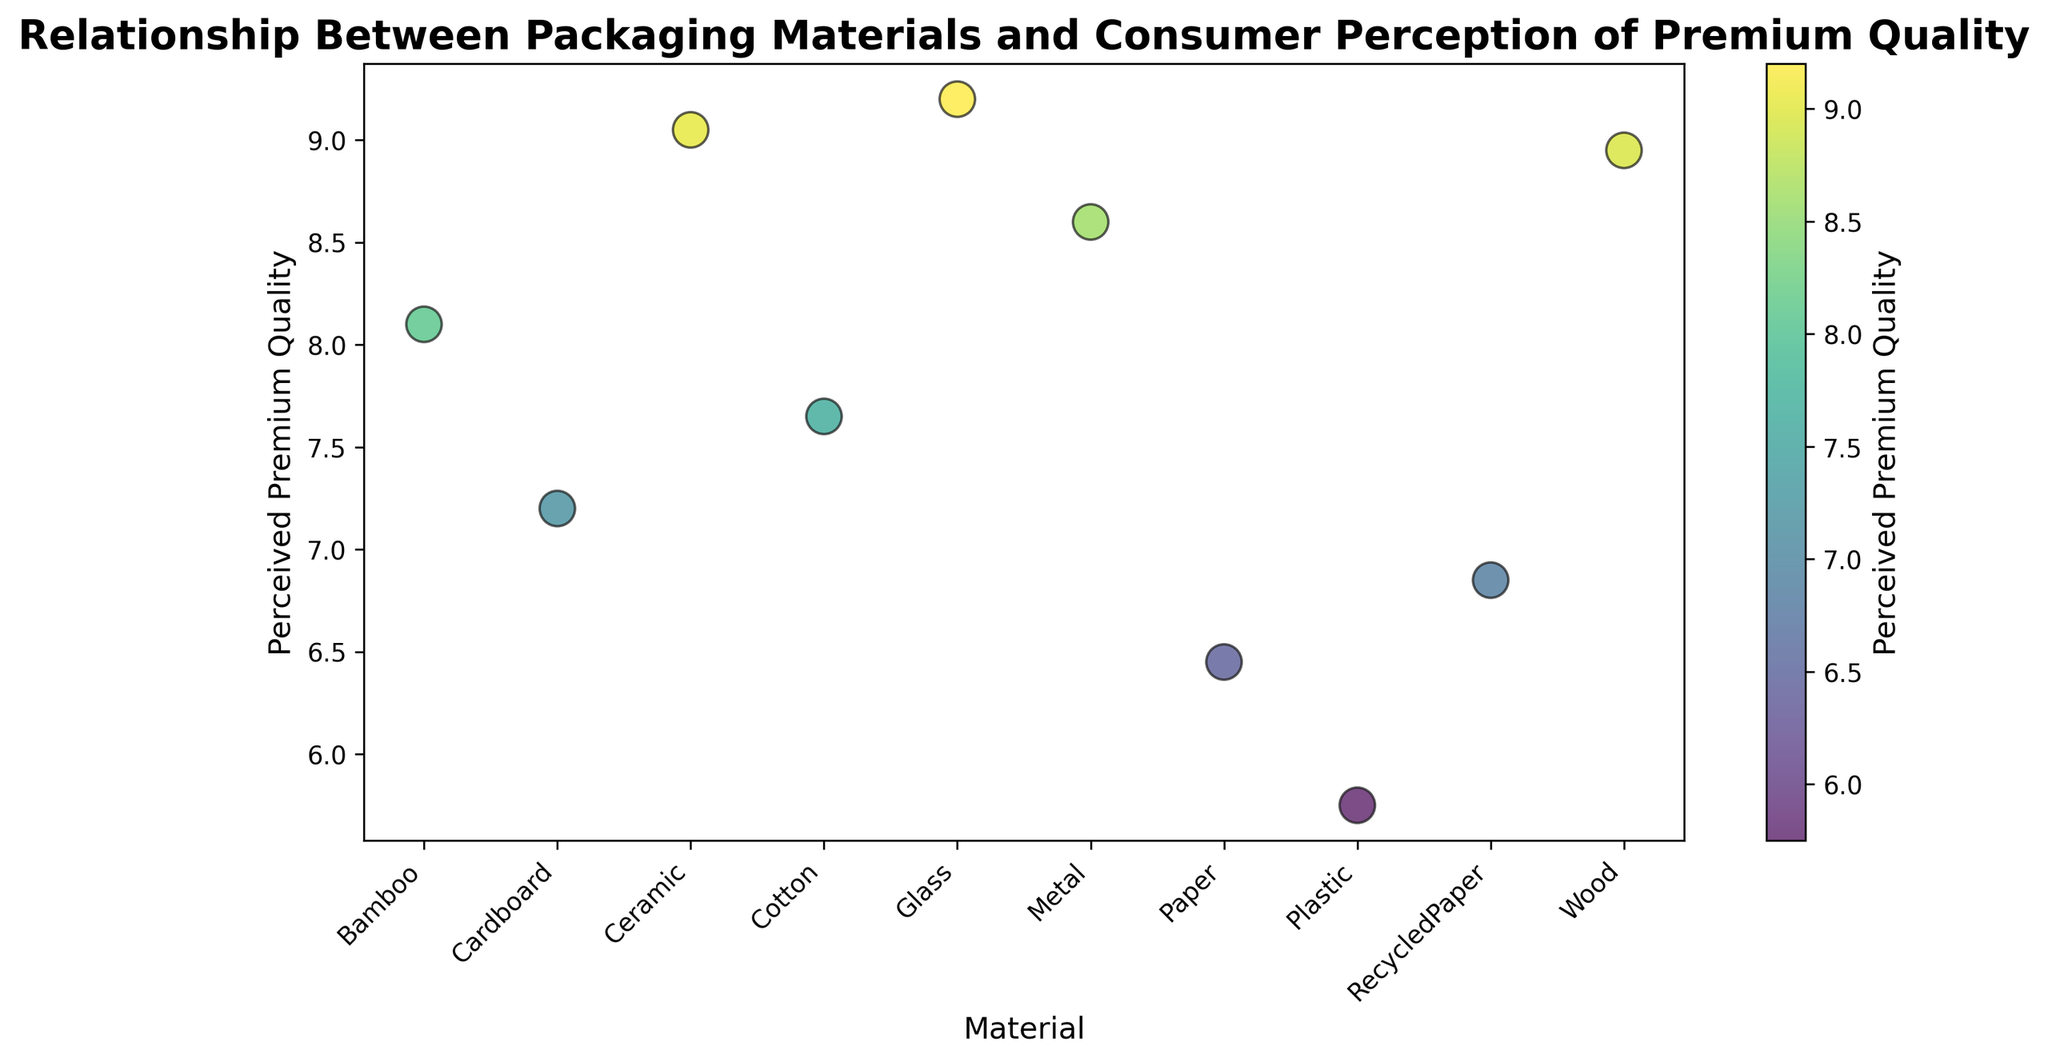Which material is perceived to have the highest premium quality? From the scatter plot, we can observe the y-axis values and see that 'Glass' ranks the highest in perceived premium quality with a rating of approximately 9.2.
Answer: Glass Which material has the lowest perceived premium quality? By examining the scatter plot, 'Plastic' appears at the lowest position on the y-axis, indicating it has the lowest perceived premium quality with an approximate rating of 5.75.
Answer: Plastic What is the perceived premium quality difference between 'Glass' and 'Plastic'? Locate 'Glass' and 'Plastic' on the scatter plot. The top 'Glass' value is about 9.2 and 'Plastic' is about 5.75. Subtracting these values gives the difference: 9.2 - 5.75 = 3.45.
Answer: 3.45 Which materials have a perceived premium quality rating above 8? Identify the markers on the scatter plot with y-axis values over 8. These are: 'Glass', 'Metal', 'Wood', 'Ceramic', and 'Bamboo'.
Answer: Glass, Metal, Wood, Ceramic, Bamboo Is the perceived premium quality for 'Cardboard' greater than that for 'Paper'? From the scatter plot, 'Cardboard' has a perceived premium quality rating around 7.2, whereas 'Paper' has a rating around 6.45. Thus, 'Cardboard' is rated higher than 'Paper'.
Answer: Yes Which material shows the second highest perceived premium quality? The second-highest mark after 'Glass' on the scatter plot is 'Ceramic', with a rating slightly above 9.0.
Answer: Ceramic What is the average perceived premium quality of 'Glass' and 'Ceramic'? 'Glass' is approximately 9.2 and 'Ceramic' is about 9.05. Thus, their average is (9.2 + 9.05) / 2 = 9.125.
Answer: 9.125 How does the perceived premium quality of 'Wood' compare to 'Bamboo'? On the scatter plot, 'Wood' has an approximate rating of 9.0, while 'Bamboo' sits around 8.1. Comparatively, 'Wood' is rated higher than 'Bamboo'.
Answer: 'Wood' is rated higher What is the perceived premium quality difference between 'Metal' and 'Cotton'? 'Metal' has a perceived premium quality around 8.6 and 'Cotton' around 7.65. The difference is 8.6 - 7.65 = 0.95.
Answer: 0.95 Does 'RecycledPaper' have a higher perceived premium quality than 'Plastic'? From the scatter plot, 'RecycledPaper' is rated around 6.85, while 'Plastic' is about 5.75. Therefore, 'RecycledPaper' has a higher perceived premium quality than 'Plastic'.
Answer: Yes 